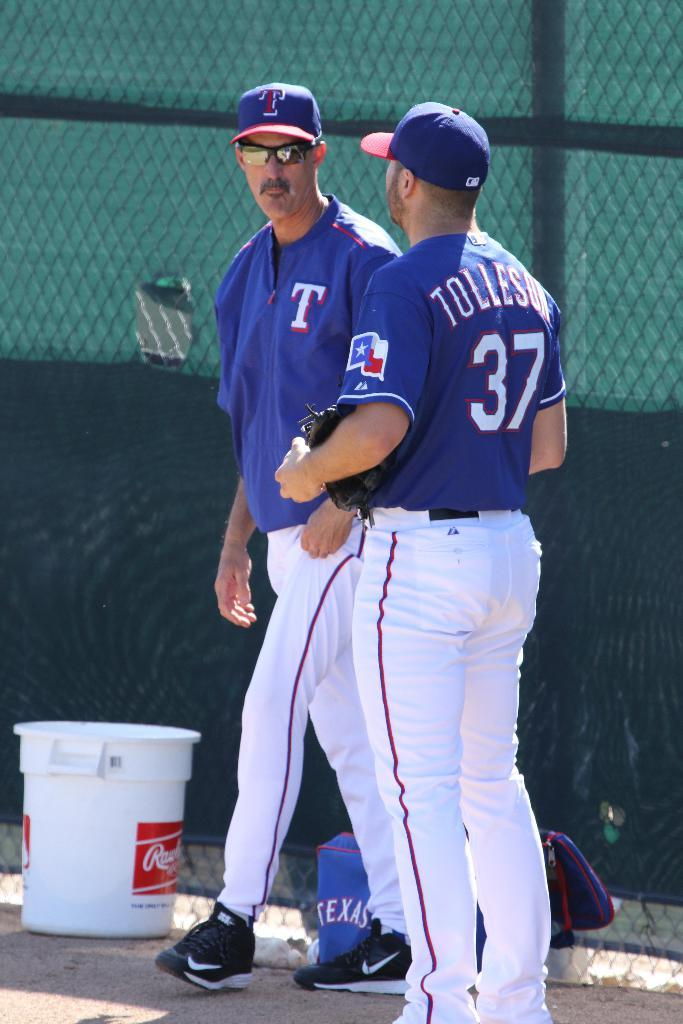<image>
Offer a succinct explanation of the picture presented. Player number 37 holds a glove as he stand near a fence. 